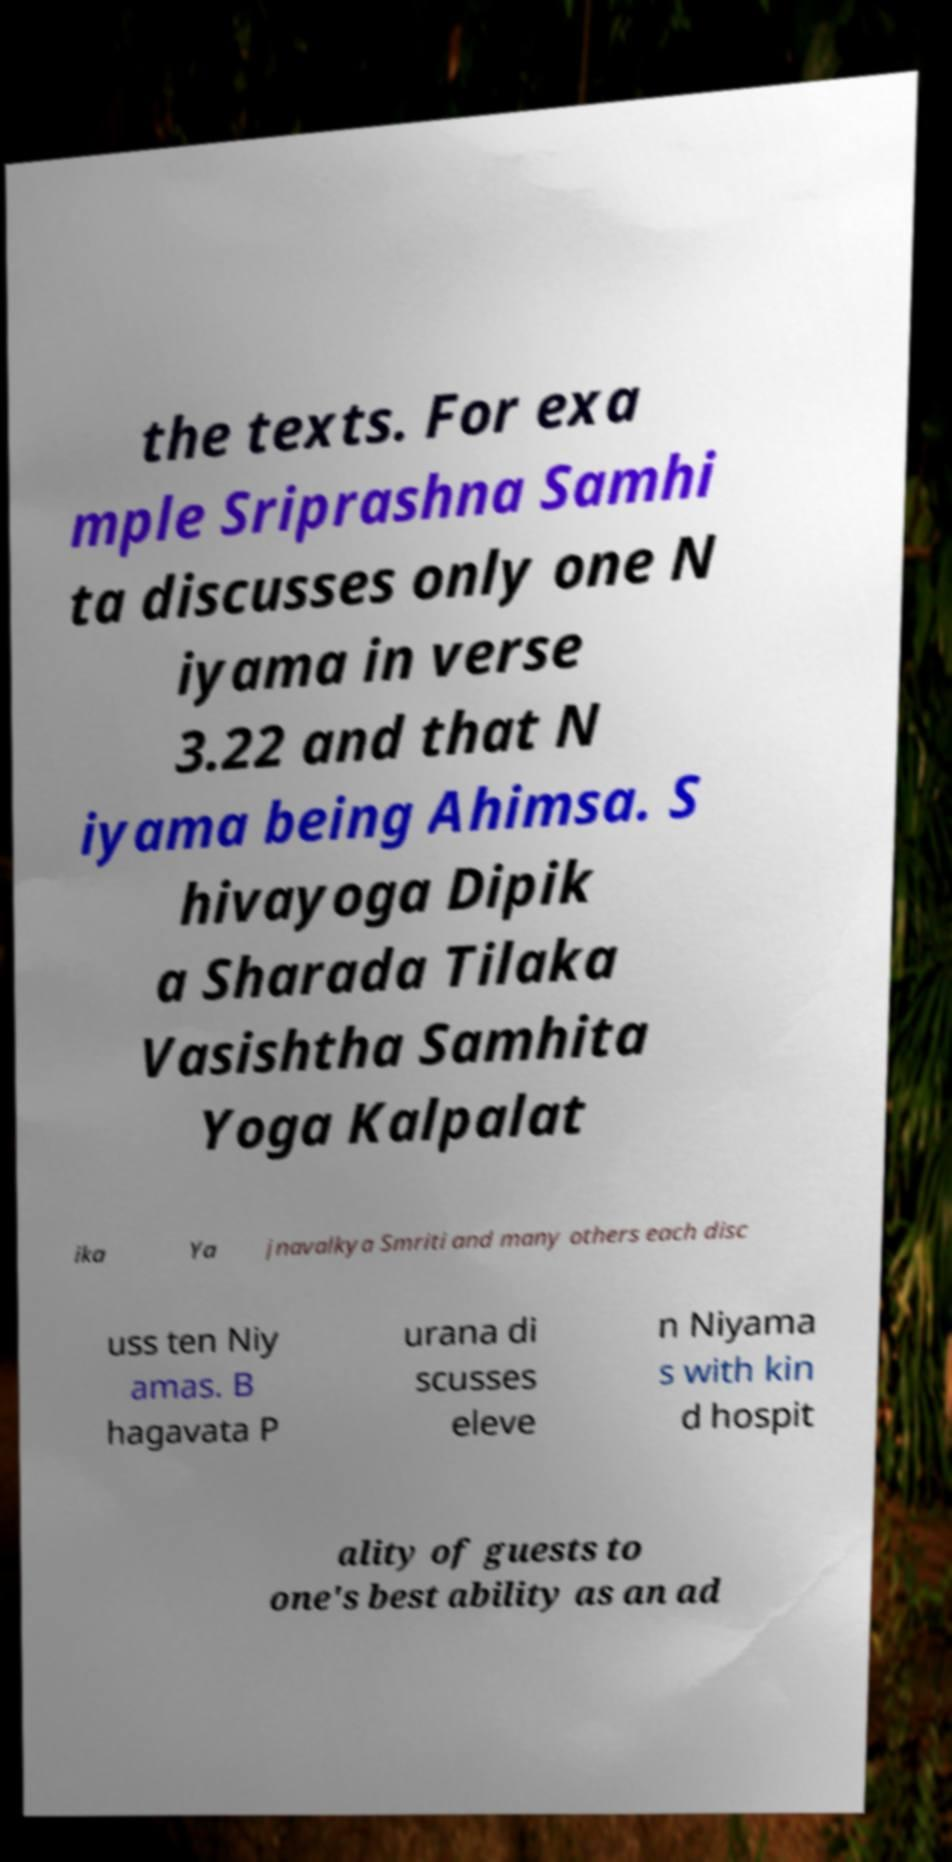Please identify and transcribe the text found in this image. the texts. For exa mple Sriprashna Samhi ta discusses only one N iyama in verse 3.22 and that N iyama being Ahimsa. S hivayoga Dipik a Sharada Tilaka Vasishtha Samhita Yoga Kalpalat ika Ya jnavalkya Smriti and many others each disc uss ten Niy amas. B hagavata P urana di scusses eleve n Niyama s with kin d hospit ality of guests to one's best ability as an ad 